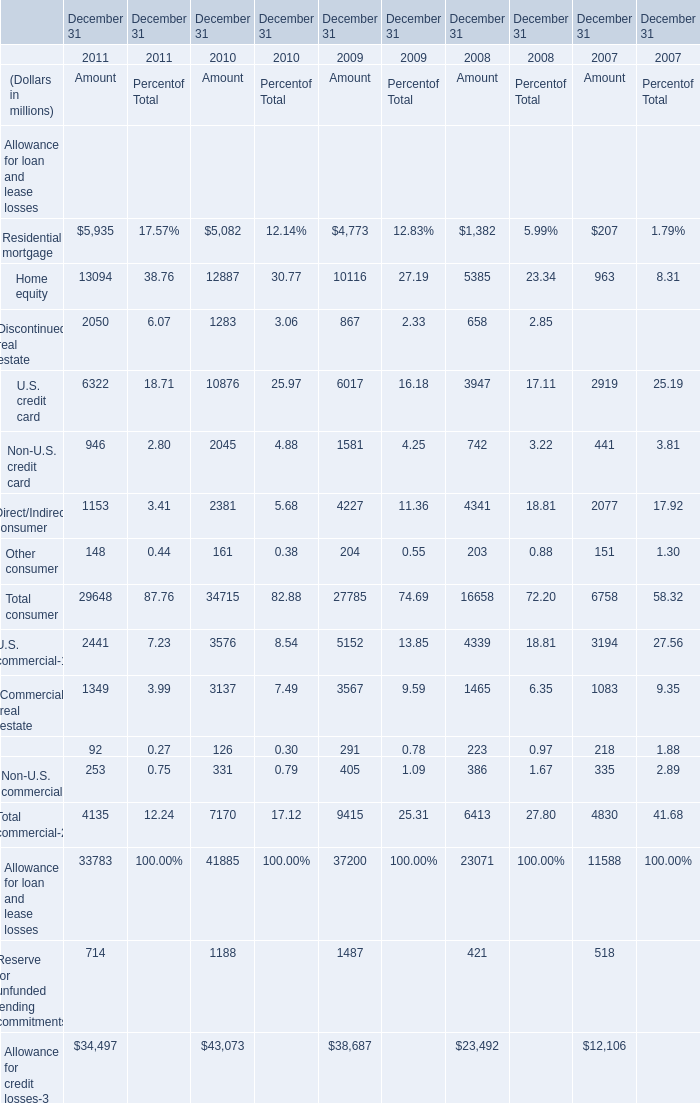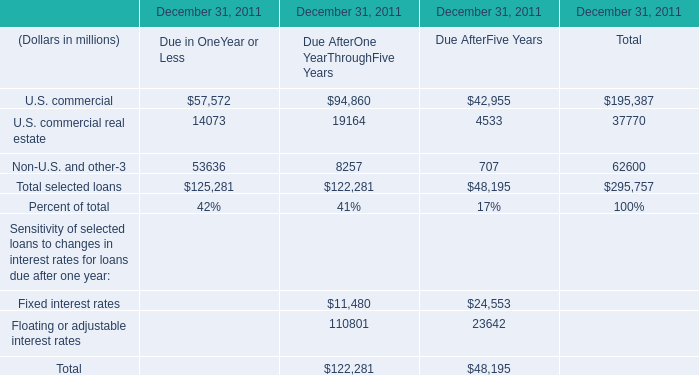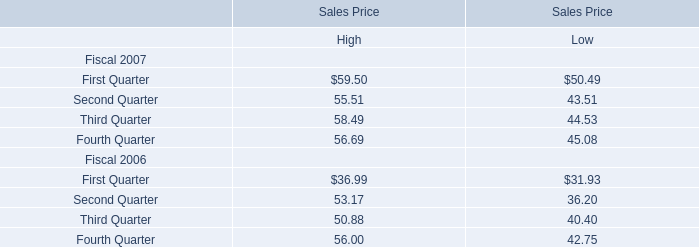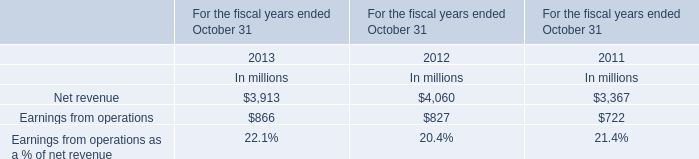What is the sum of U.S. commercial of December 31 2011 Amount, and U.S. commercial of December 31, 2011 Due AfterOne YearThroughFive Years ? 
Computations: (2441.0 + 94860.0)
Answer: 97301.0. 